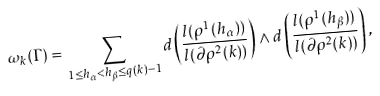<formula> <loc_0><loc_0><loc_500><loc_500>\omega _ { k } ( \Gamma ) = \sum _ { 1 \leq h _ { \alpha } < h _ { \beta } \leq q ( k ) - 1 } d \left ( \frac { l ( \rho ^ { 1 } ( h _ { \alpha } ) ) } { l ( \partial \rho ^ { 2 } ( k ) ) } \right ) \wedge d \left ( \frac { l ( \rho ^ { 1 } ( h _ { \beta } ) ) } { l ( \partial \rho ^ { 2 } ( k ) ) } \right ) ,</formula> 